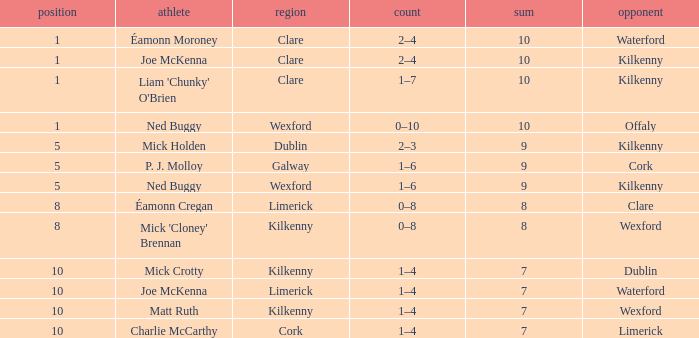Which Total has a County of kilkenny, and a Tally of 1–4, and a Rank larger than 10? None. 